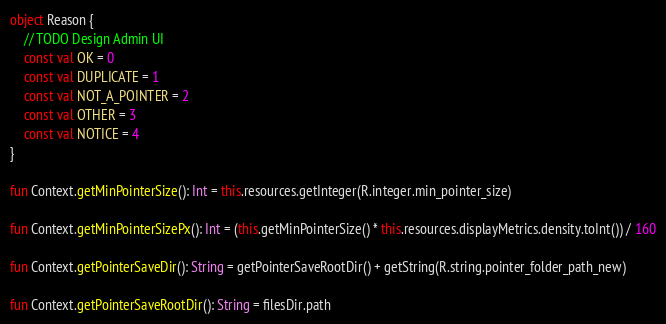Convert code to text. <code><loc_0><loc_0><loc_500><loc_500><_Kotlin_>
object Reason {
    // TODO Design Admin UI
    const val OK = 0
    const val DUPLICATE = 1
    const val NOT_A_POINTER = 2
    const val OTHER = 3
    const val NOTICE = 4
}

fun Context.getMinPointerSize(): Int = this.resources.getInteger(R.integer.min_pointer_size)

fun Context.getMinPointerSizePx(): Int = (this.getMinPointerSize() * this.resources.displayMetrics.density.toInt()) / 160

fun Context.getPointerSaveDir(): String = getPointerSaveRootDir() + getString(R.string.pointer_folder_path_new)

fun Context.getPointerSaveRootDir(): String = filesDir.path
</code> 